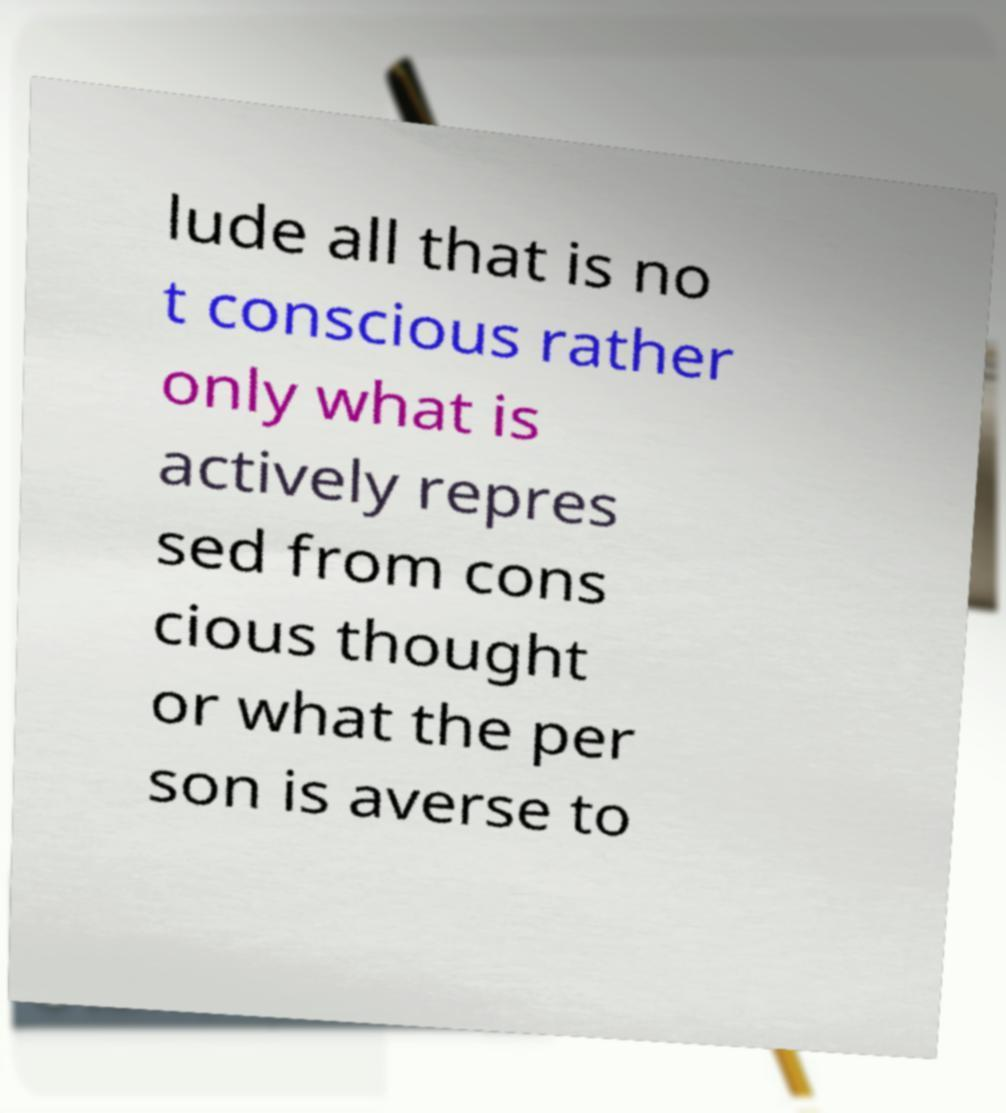There's text embedded in this image that I need extracted. Can you transcribe it verbatim? lude all that is no t conscious rather only what is actively repres sed from cons cious thought or what the per son is averse to 